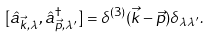<formula> <loc_0><loc_0><loc_500><loc_500>[ \hat { a } _ { \vec { k } , \lambda } , \hat { a } ^ { \dagger } _ { \vec { p } , \lambda ^ { \prime } } ] = \delta ^ { ( 3 ) } ( \vec { k } - \vec { p } ) \delta _ { \lambda \lambda ^ { \prime } } .</formula> 